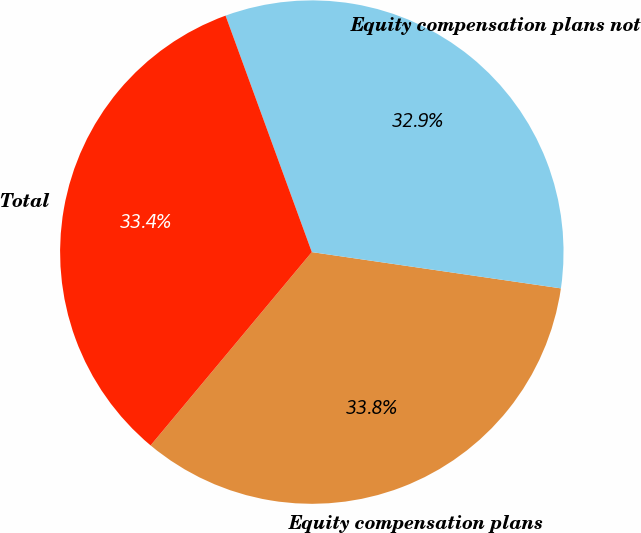Convert chart to OTSL. <chart><loc_0><loc_0><loc_500><loc_500><pie_chart><fcel>Equity compensation plans<fcel>Equity compensation plans not<fcel>Total<nl><fcel>33.76%<fcel>32.87%<fcel>33.37%<nl></chart> 